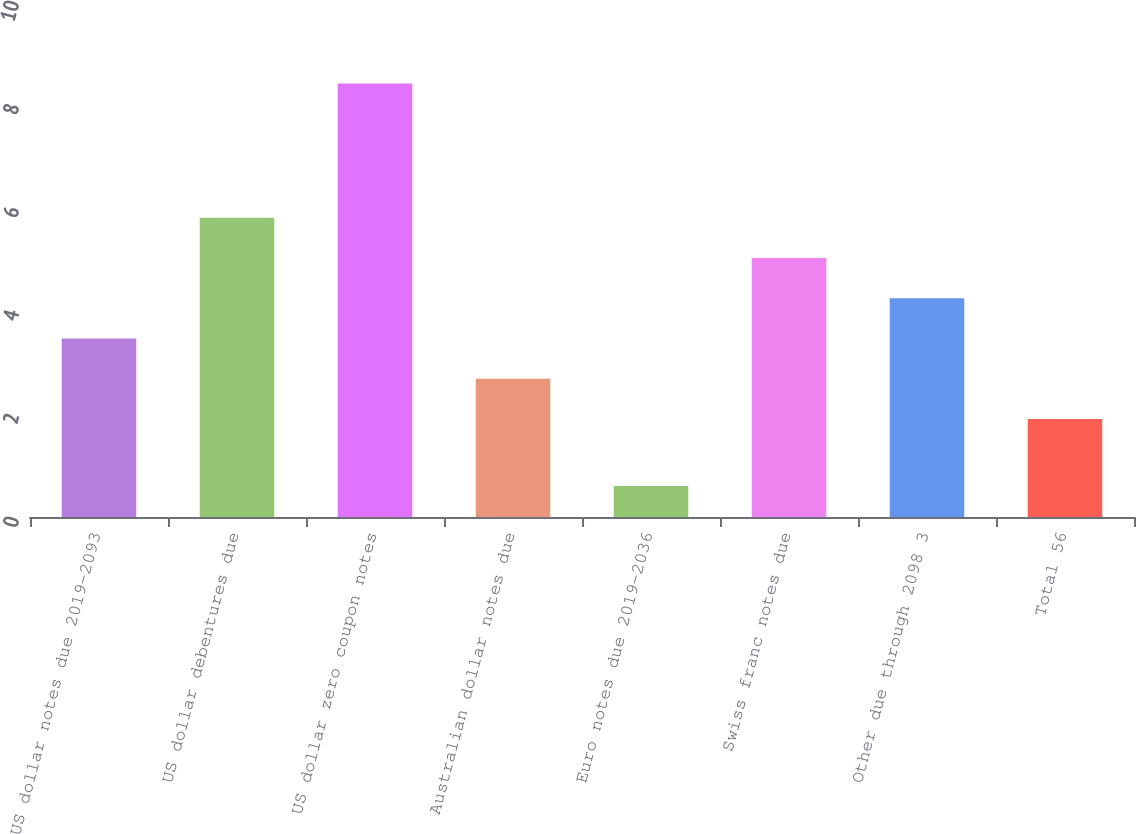<chart> <loc_0><loc_0><loc_500><loc_500><bar_chart><fcel>US dollar notes due 2019-2093<fcel>US dollar debentures due<fcel>US dollar zero coupon notes<fcel>Australian dollar notes due<fcel>Euro notes due 2019-2036<fcel>Swiss franc notes due<fcel>Other due through 2098 3<fcel>Total 56<nl><fcel>3.46<fcel>5.8<fcel>8.4<fcel>2.68<fcel>0.6<fcel>5.02<fcel>4.24<fcel>1.9<nl></chart> 